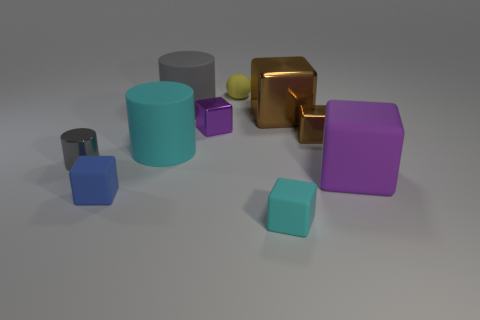How many things are either big blue matte blocks or gray things left of the small blue rubber block?
Offer a very short reply. 1. There is a cylinder that is on the left side of the big cyan object; is it the same size as the purple block in front of the small gray metal cylinder?
Make the answer very short. No. What number of other things are the same color as the matte ball?
Offer a terse response. 0. There is a gray rubber thing; is it the same size as the brown cube that is behind the small brown shiny block?
Make the answer very short. Yes. There is a cyan object that is left of the metal block left of the yellow ball; what size is it?
Give a very brief answer. Large. What color is the tiny metal thing that is the same shape as the large gray object?
Offer a very short reply. Gray. Do the yellow rubber thing and the gray shiny cylinder have the same size?
Keep it short and to the point. Yes. Is the number of large purple matte blocks behind the big cyan thing the same as the number of red rubber balls?
Give a very brief answer. Yes. Are there any tiny cylinders that are on the right side of the cyan thing in front of the big matte cube?
Offer a very short reply. No. What is the size of the purple object on the left side of the small matte object on the right side of the small rubber thing behind the blue cube?
Ensure brevity in your answer.  Small. 